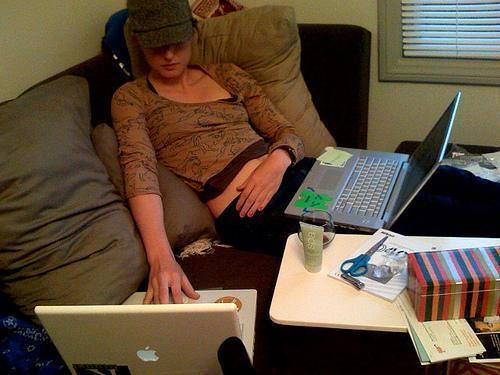How many women are in the photo?
Give a very brief answer. 1. 